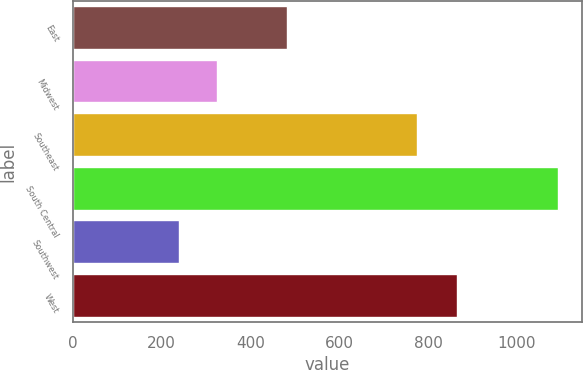Convert chart to OTSL. <chart><loc_0><loc_0><loc_500><loc_500><bar_chart><fcel>East<fcel>Midwest<fcel>Southeast<fcel>South Central<fcel>Southwest<fcel>West<nl><fcel>482.6<fcel>324.86<fcel>776.1<fcel>1092.2<fcel>239.6<fcel>865.1<nl></chart> 